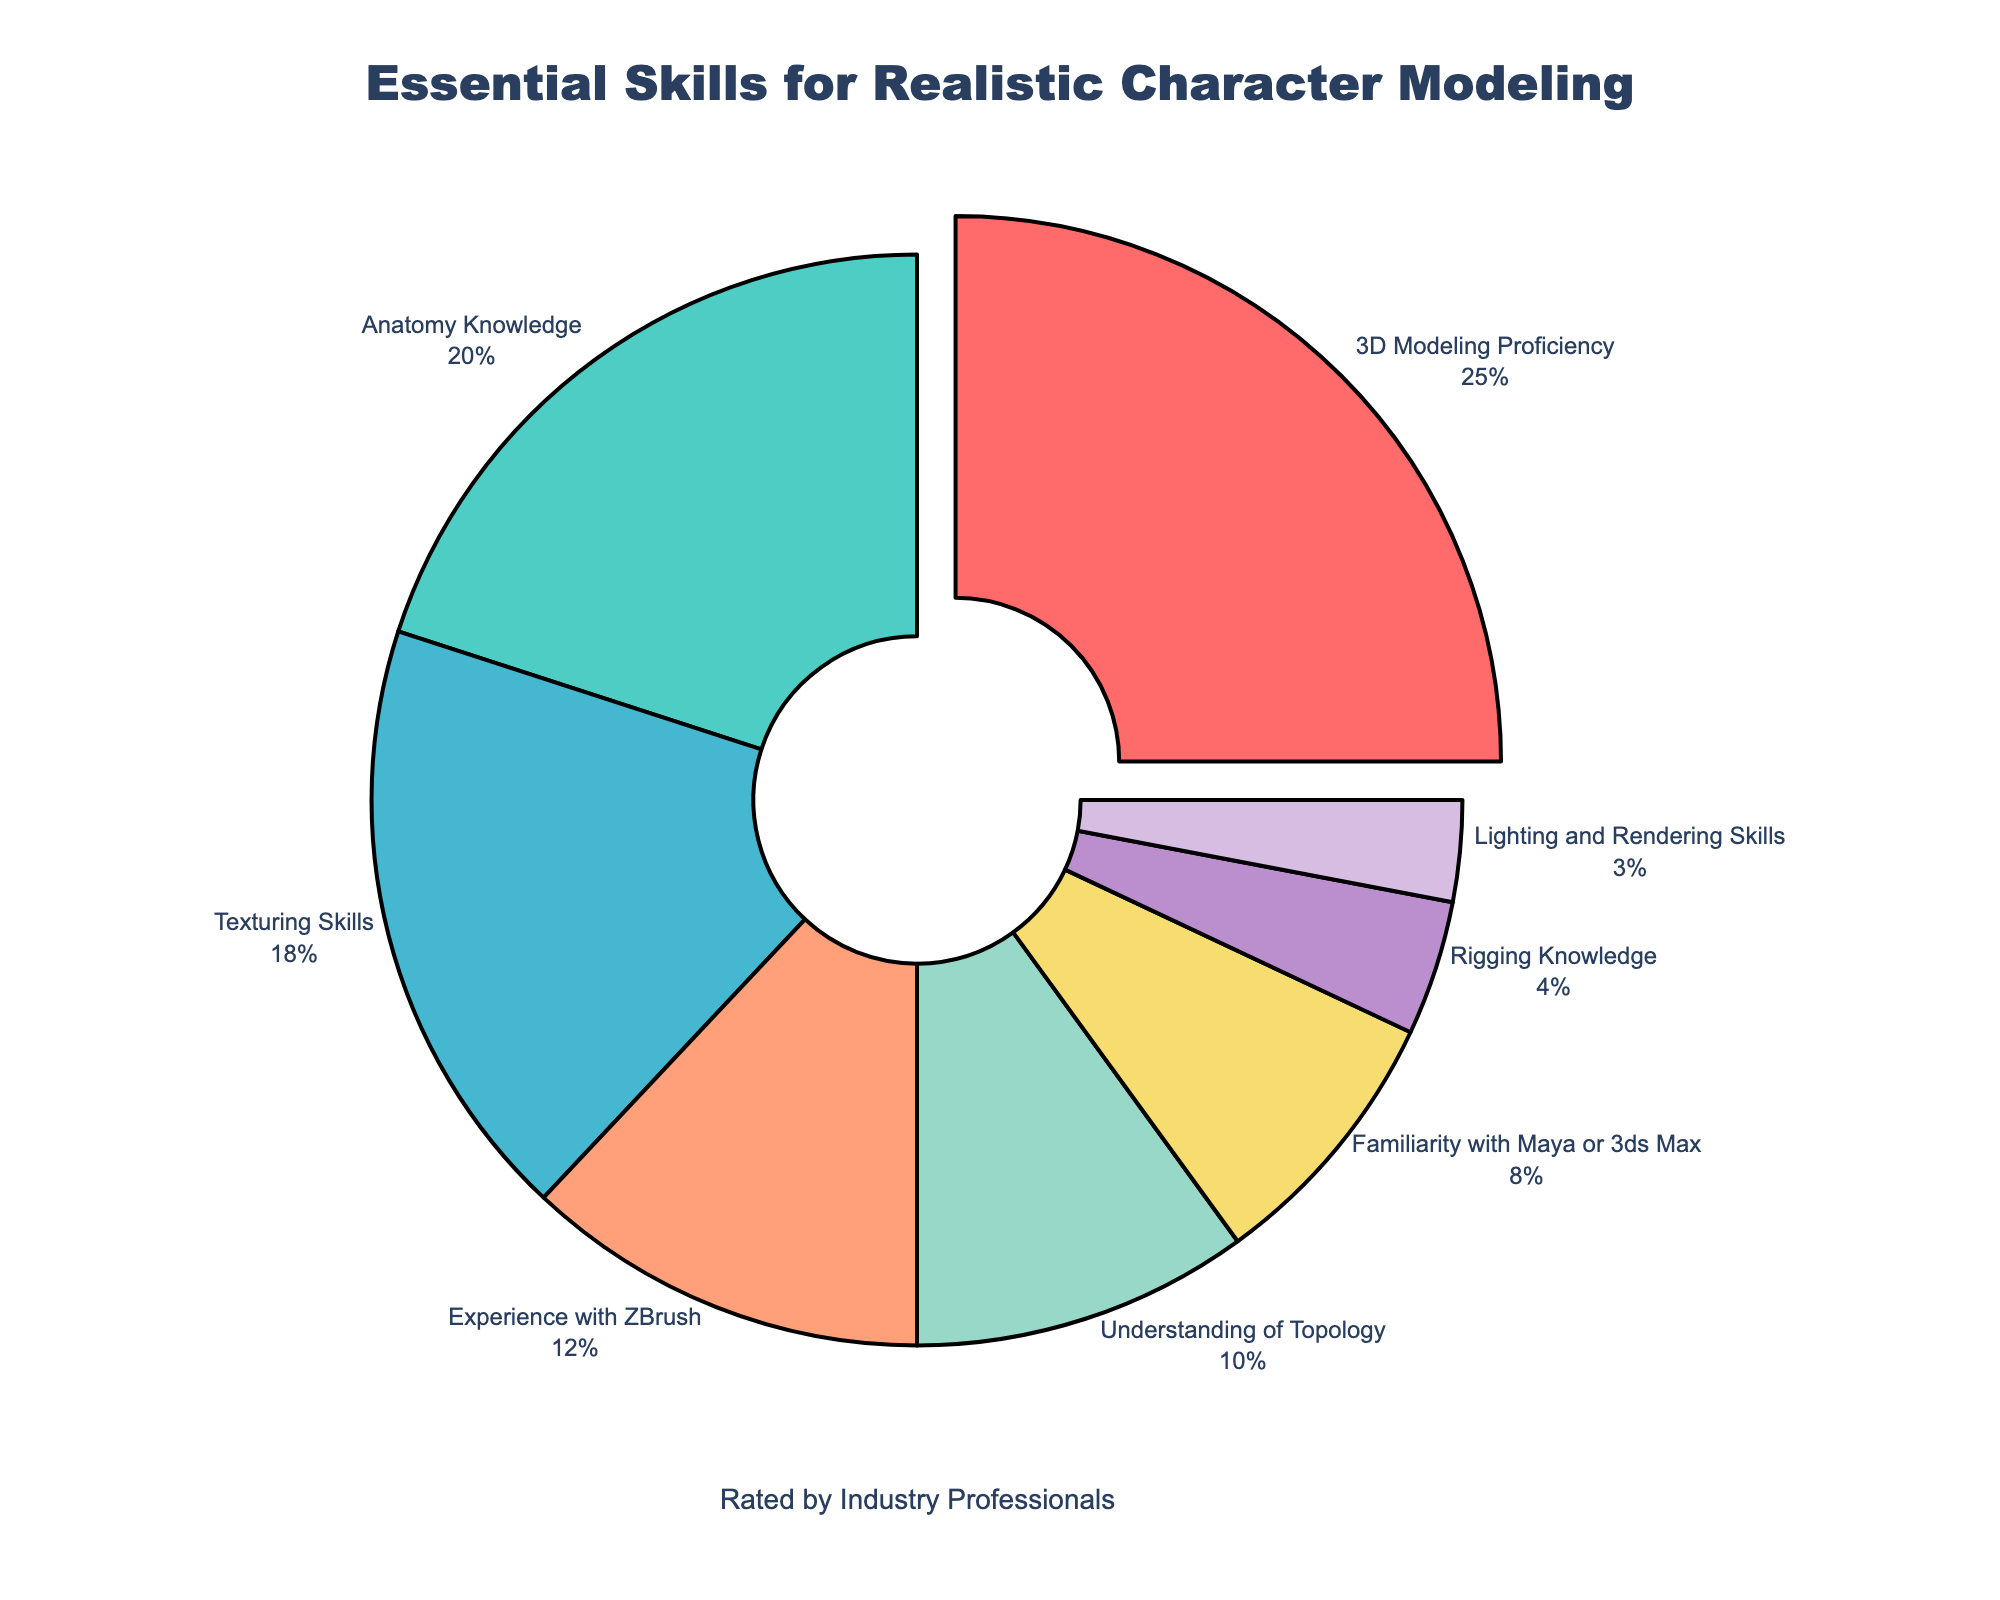What skill has the highest percentage? The skill with the highest percentage is identified by the largest segment on the pie chart. The segment labeled "3D Modeling Proficiency" seems to be the largest, with a 25% share.
Answer: 3D Modeling Proficiency What's the combined percentage for Anatomy Knowledge and Texturing Skills? To find the combined percentage, sum the percentages of "Anatomy Knowledge" and "Texturing Skills". Anatomy Knowledge is 20% and Texturing Skills is 18%, so 20% + 18% = 38%.
Answer: 38% Which skill has the smallest percentage? The skill with the smallest percentage is identified by the smallest segment on the pie chart. The segment labeled "Lighting and Rendering Skills" appears to be the smallest, with a 3% share.
Answer: Lighting and Rendering Skills Is the percentage for Understanding of Topology greater than that for Familiarity with Maya or 3ds Max? Compare the values given for each skill. The percentage for Understanding of Topology is 10%, whereas for Familiarity with Maya or 3ds Max, it is 8%. Since 10% is greater than 8%, the answer is yes.
Answer: Yes What skills together make up more than 50% of the total? Add the percentages starting from the largest until the cumulative percentage exceeds 50%. The percentages are: 3D Modeling Proficiency (25%), Anatomy Knowledge (20%), and Texturing Skills (18%). Adding them: 25% + 20% + 18% = 63%. Thus, these three skills together make up more than 50%.
Answer: 3D Modeling Proficiency, Anatomy Knowledge, Texturing Skills Which color represents the Experience with ZBrush segment? The segment for "Experience with ZBrush" can be identified by its color. The figure uses distinct colors for each segment, and "Experience with ZBrush" is represented by orange.
Answer: Orange What's the difference in percentage between Texturing Skills and Rigging Knowledge? Subtract the percentage of Rigging Knowledge from Texturing Skills. Texturing Skills is 18% and Rigging Knowledge is 4%, so 18% - 4% = 14%.
Answer: 14% What is the total percentage for skills related to software proficiency (Experience with ZBrush, Familiarity with Maya or 3ds Max)? Add the percentages for “Experience with ZBrush” and “Familiarity with Maya or 3ds Max”. Experience with ZBrush is 12% and Familiarity with Maya or 3ds Max is 8%, so 12% + 8% = 20%.
Answer: 20% 